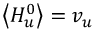Convert formula to latex. <formula><loc_0><loc_0><loc_500><loc_500>\left \langle H _ { u } ^ { 0 } \right \rangle = v _ { u }</formula> 